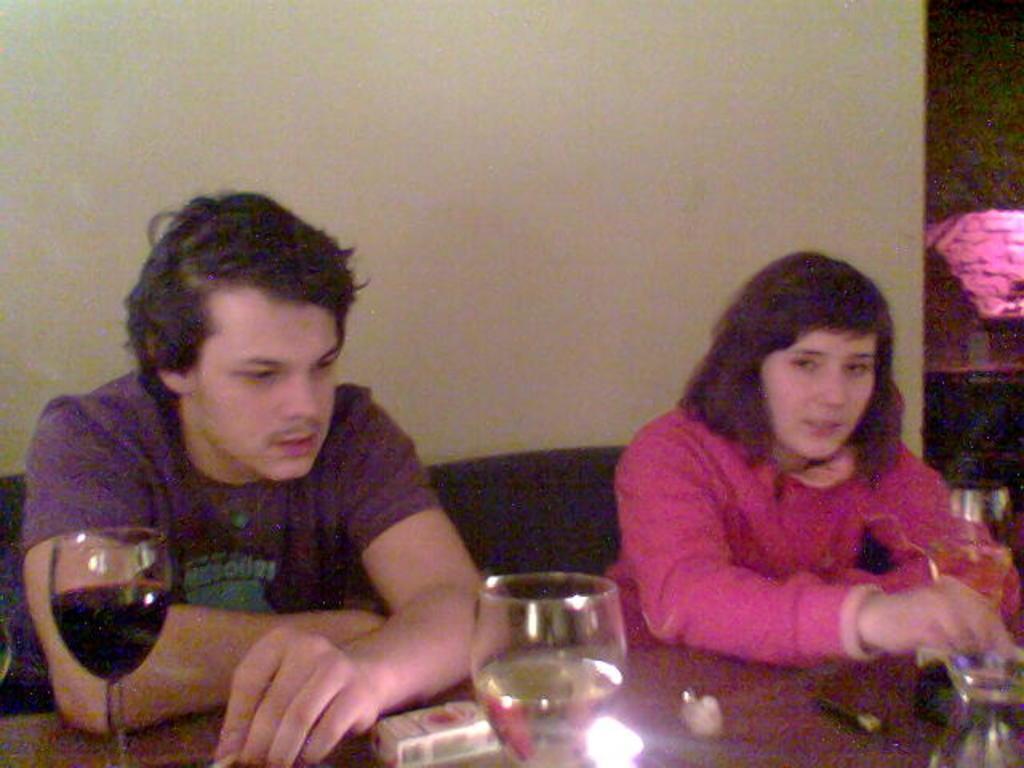In one or two sentences, can you explain what this image depicts? In this picture there is a man and a woman sitting in this chair in front of a table on which some wine glasses were placed. In the background there is a wall. 